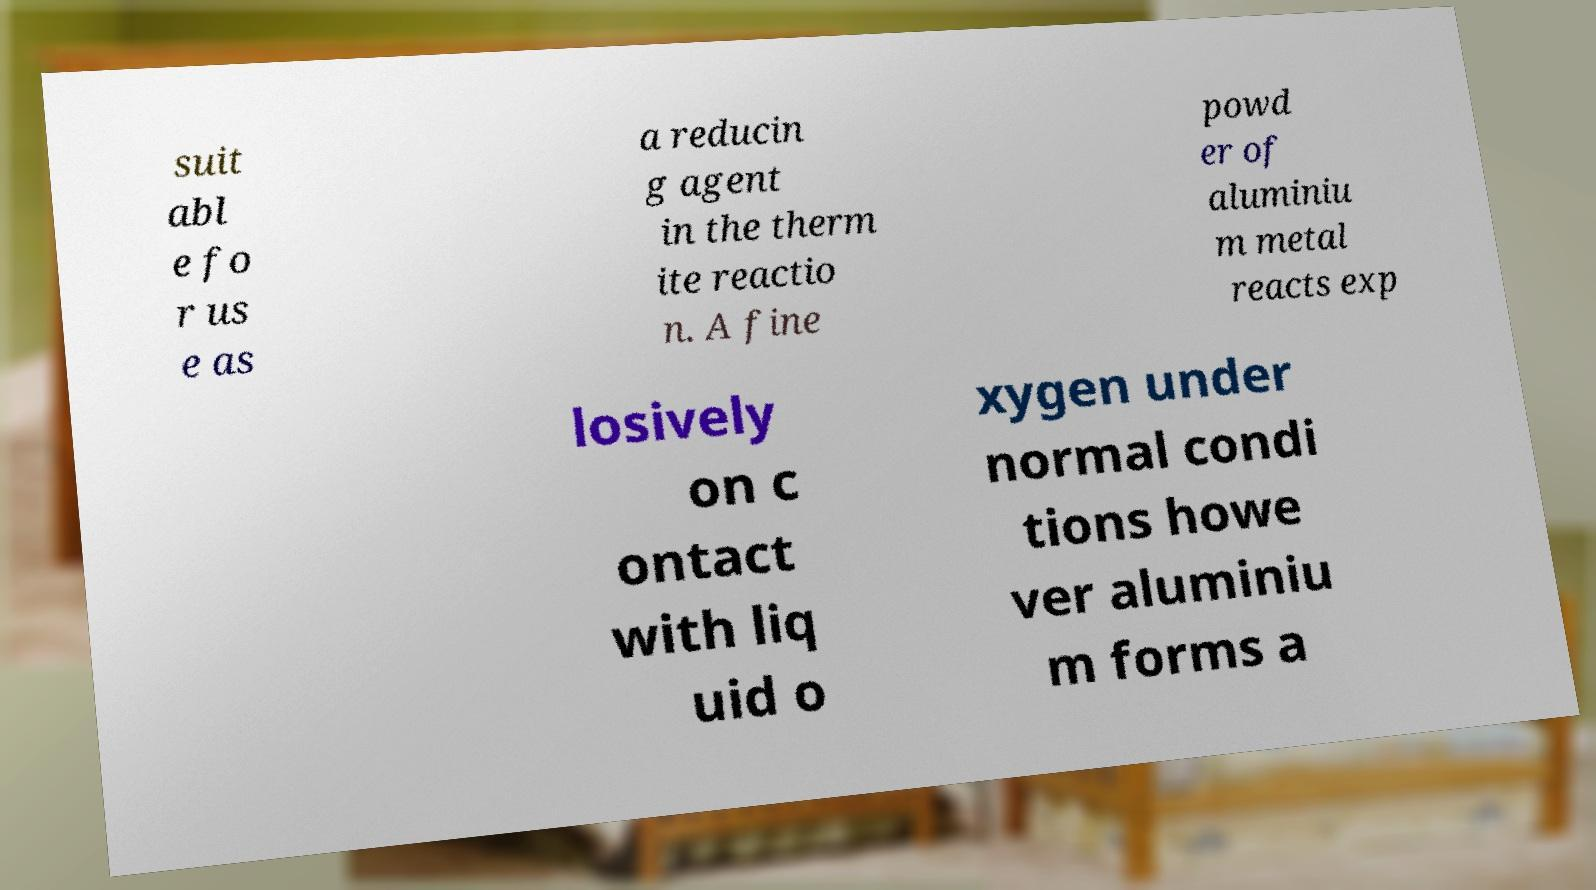Can you accurately transcribe the text from the provided image for me? suit abl e fo r us e as a reducin g agent in the therm ite reactio n. A fine powd er of aluminiu m metal reacts exp losively on c ontact with liq uid o xygen under normal condi tions howe ver aluminiu m forms a 